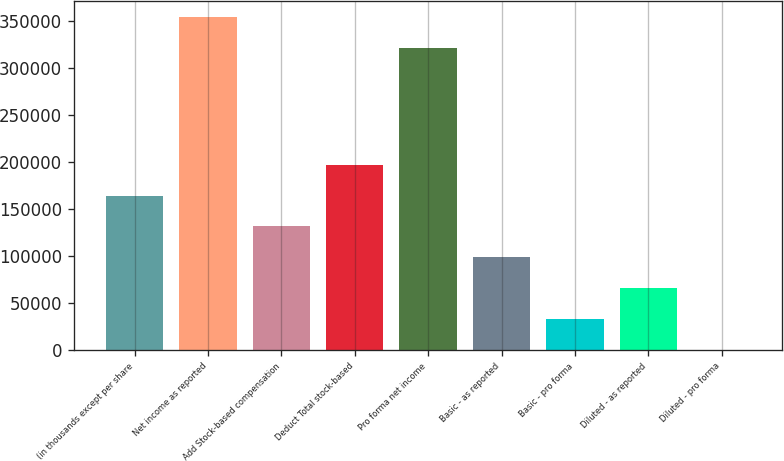Convert chart. <chart><loc_0><loc_0><loc_500><loc_500><bar_chart><fcel>(in thousands except per share<fcel>Net income as reported<fcel>Add Stock-based compensation<fcel>Deduct Total stock-based<fcel>Pro forma net income<fcel>Basic - as reported<fcel>Basic - pro forma<fcel>Diluted - as reported<fcel>Diluted - pro forma<nl><fcel>164358<fcel>354253<fcel>131487<fcel>197228<fcel>321383<fcel>98616.8<fcel>32875.9<fcel>65746.4<fcel>5.43<nl></chart> 